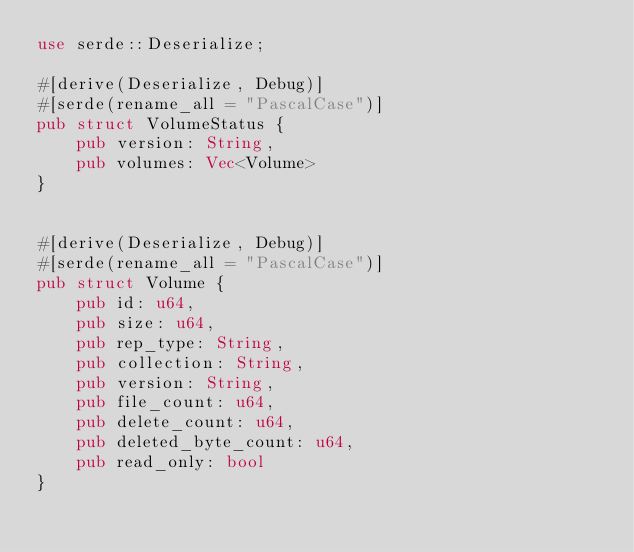<code> <loc_0><loc_0><loc_500><loc_500><_Rust_>use serde::Deserialize;

#[derive(Deserialize, Debug)]
#[serde(rename_all = "PascalCase")]
pub struct VolumeStatus {
    pub version: String,
    pub volumes: Vec<Volume>
}


#[derive(Deserialize, Debug)]
#[serde(rename_all = "PascalCase")]
pub struct Volume {
    pub id: u64,
    pub size: u64,
    pub rep_type: String,
    pub collection: String,
    pub version: String,
    pub file_count: u64,
    pub delete_count: u64,
    pub deleted_byte_count: u64,
    pub read_only: bool
}

</code> 